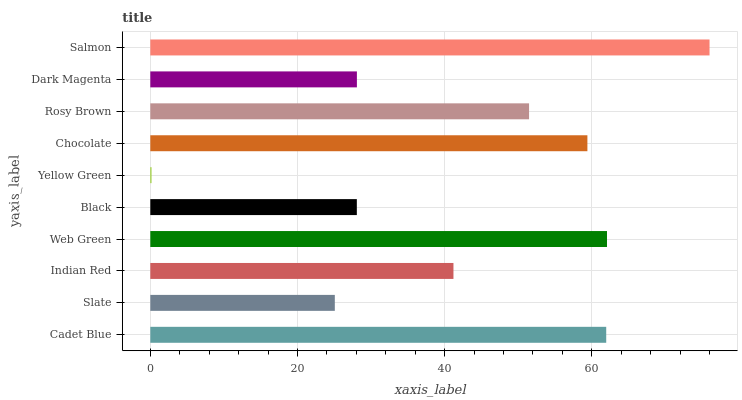Is Yellow Green the minimum?
Answer yes or no. Yes. Is Salmon the maximum?
Answer yes or no. Yes. Is Slate the minimum?
Answer yes or no. No. Is Slate the maximum?
Answer yes or no. No. Is Cadet Blue greater than Slate?
Answer yes or no. Yes. Is Slate less than Cadet Blue?
Answer yes or no. Yes. Is Slate greater than Cadet Blue?
Answer yes or no. No. Is Cadet Blue less than Slate?
Answer yes or no. No. Is Rosy Brown the high median?
Answer yes or no. Yes. Is Indian Red the low median?
Answer yes or no. Yes. Is Cadet Blue the high median?
Answer yes or no. No. Is Web Green the low median?
Answer yes or no. No. 